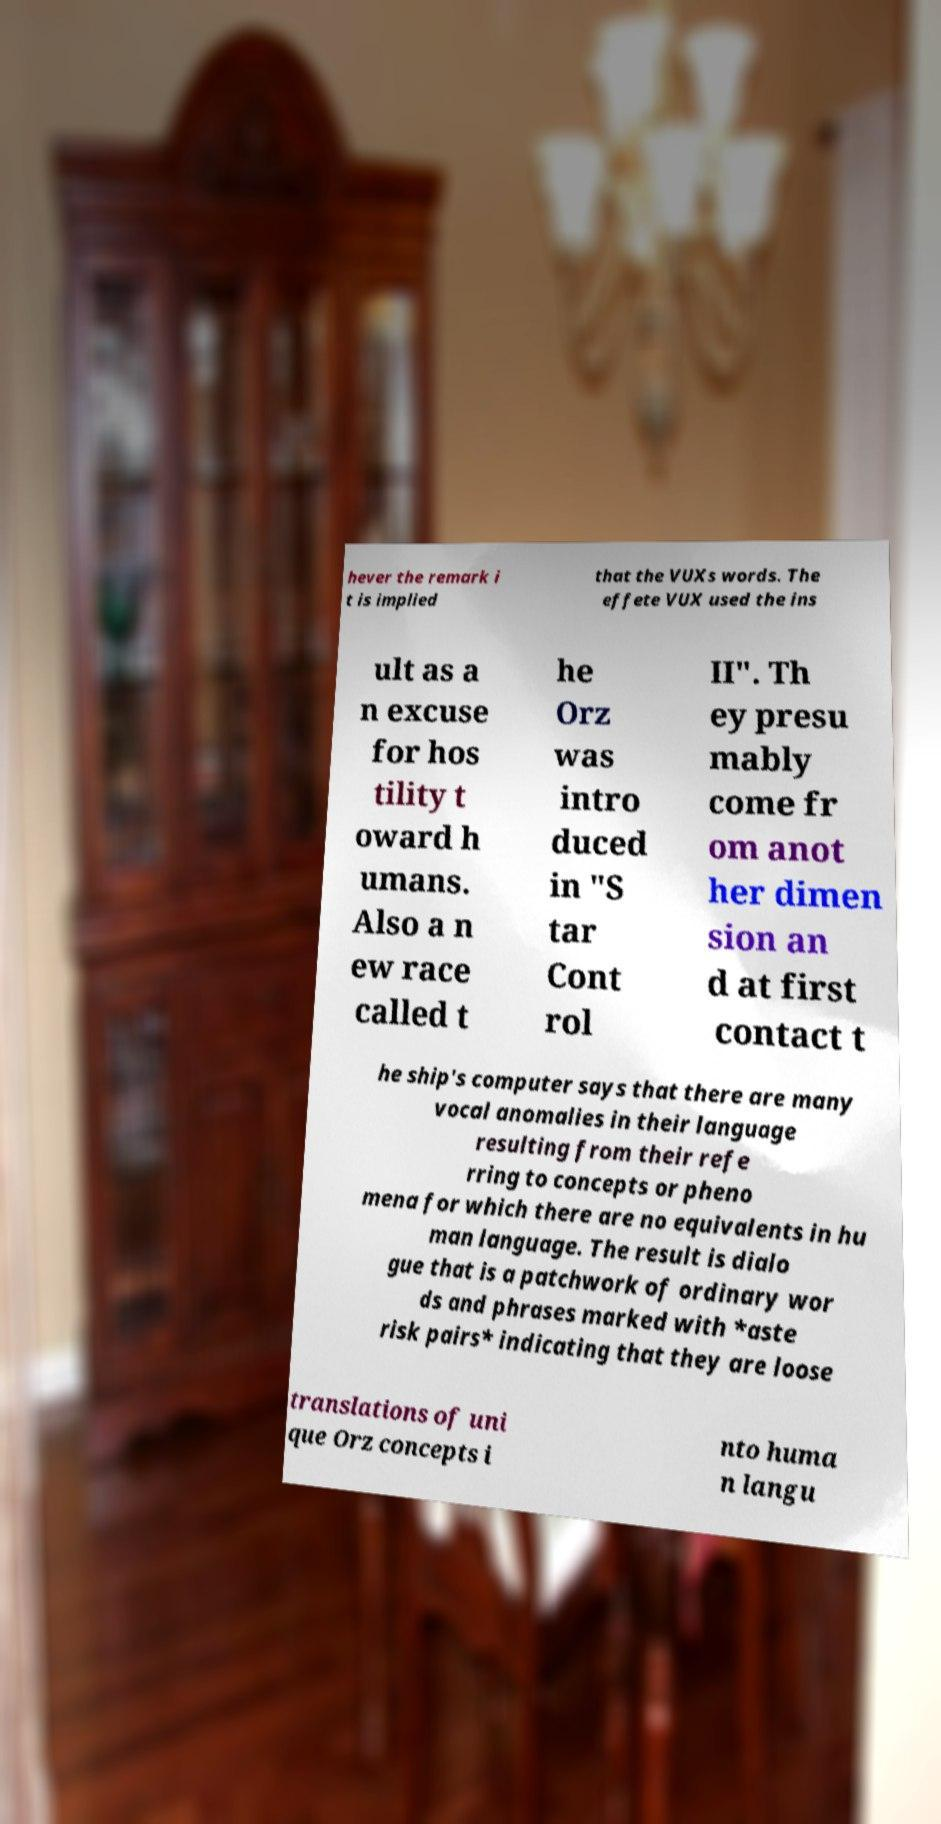There's text embedded in this image that I need extracted. Can you transcribe it verbatim? hever the remark i t is implied that the VUXs words. The effete VUX used the ins ult as a n excuse for hos tility t oward h umans. Also a n ew race called t he Orz was intro duced in "S tar Cont rol II". Th ey presu mably come fr om anot her dimen sion an d at first contact t he ship's computer says that there are many vocal anomalies in their language resulting from their refe rring to concepts or pheno mena for which there are no equivalents in hu man language. The result is dialo gue that is a patchwork of ordinary wor ds and phrases marked with *aste risk pairs* indicating that they are loose translations of uni que Orz concepts i nto huma n langu 